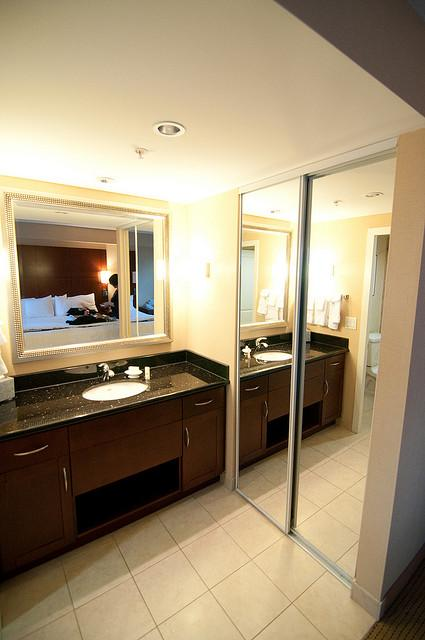What is behind the two tall mirrors? Please explain your reasoning. closet. The mirrors have a closet behind them. 